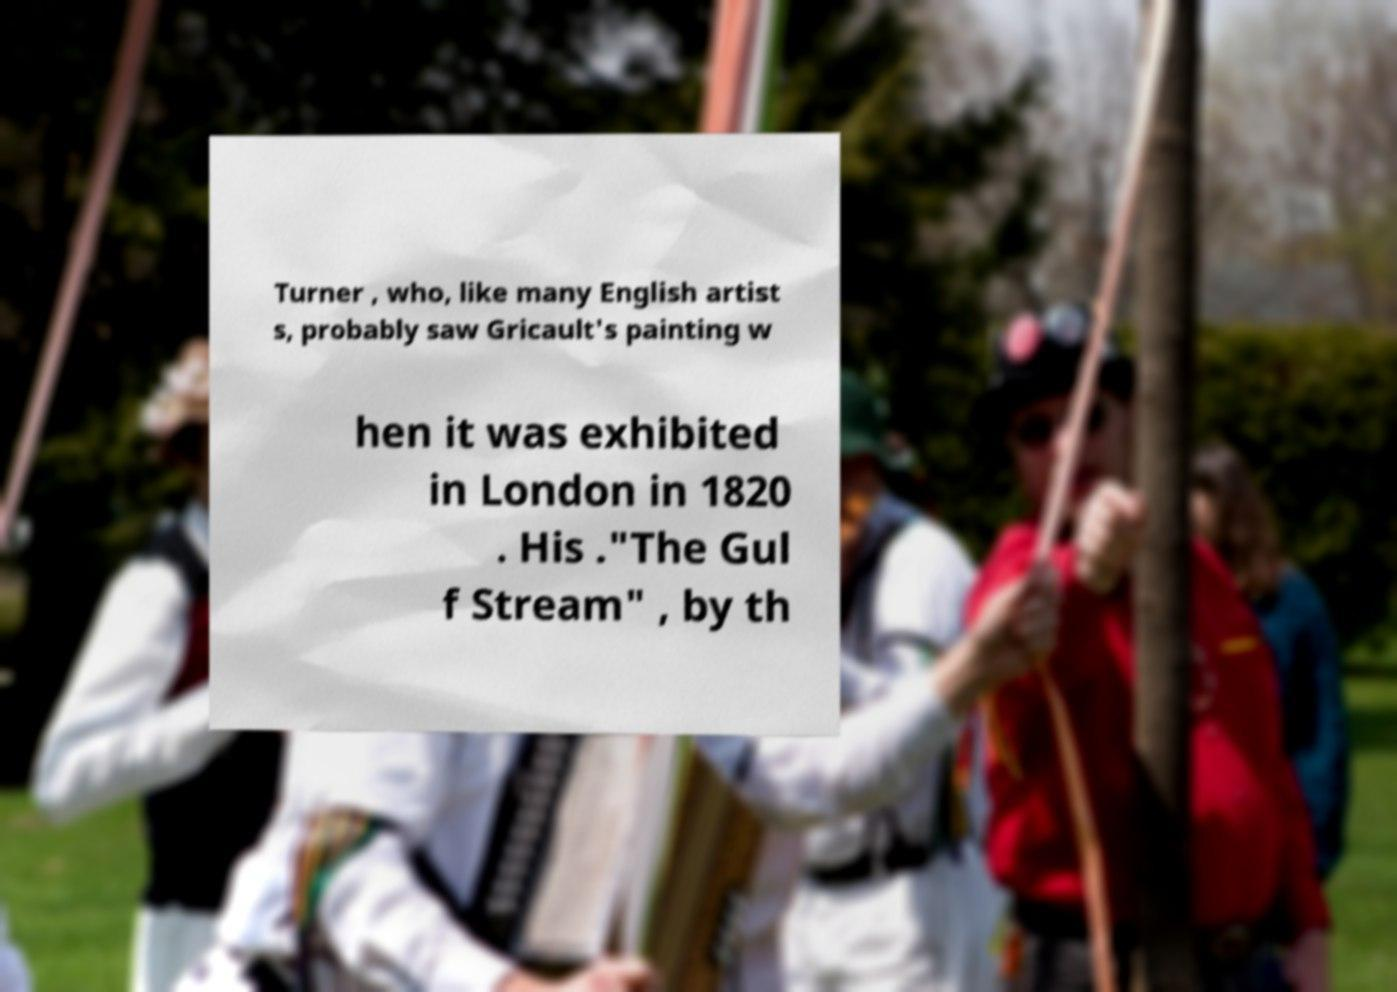Please read and relay the text visible in this image. What does it say? Turner , who, like many English artist s, probably saw Gricault's painting w hen it was exhibited in London in 1820 . His ."The Gul f Stream" , by th 